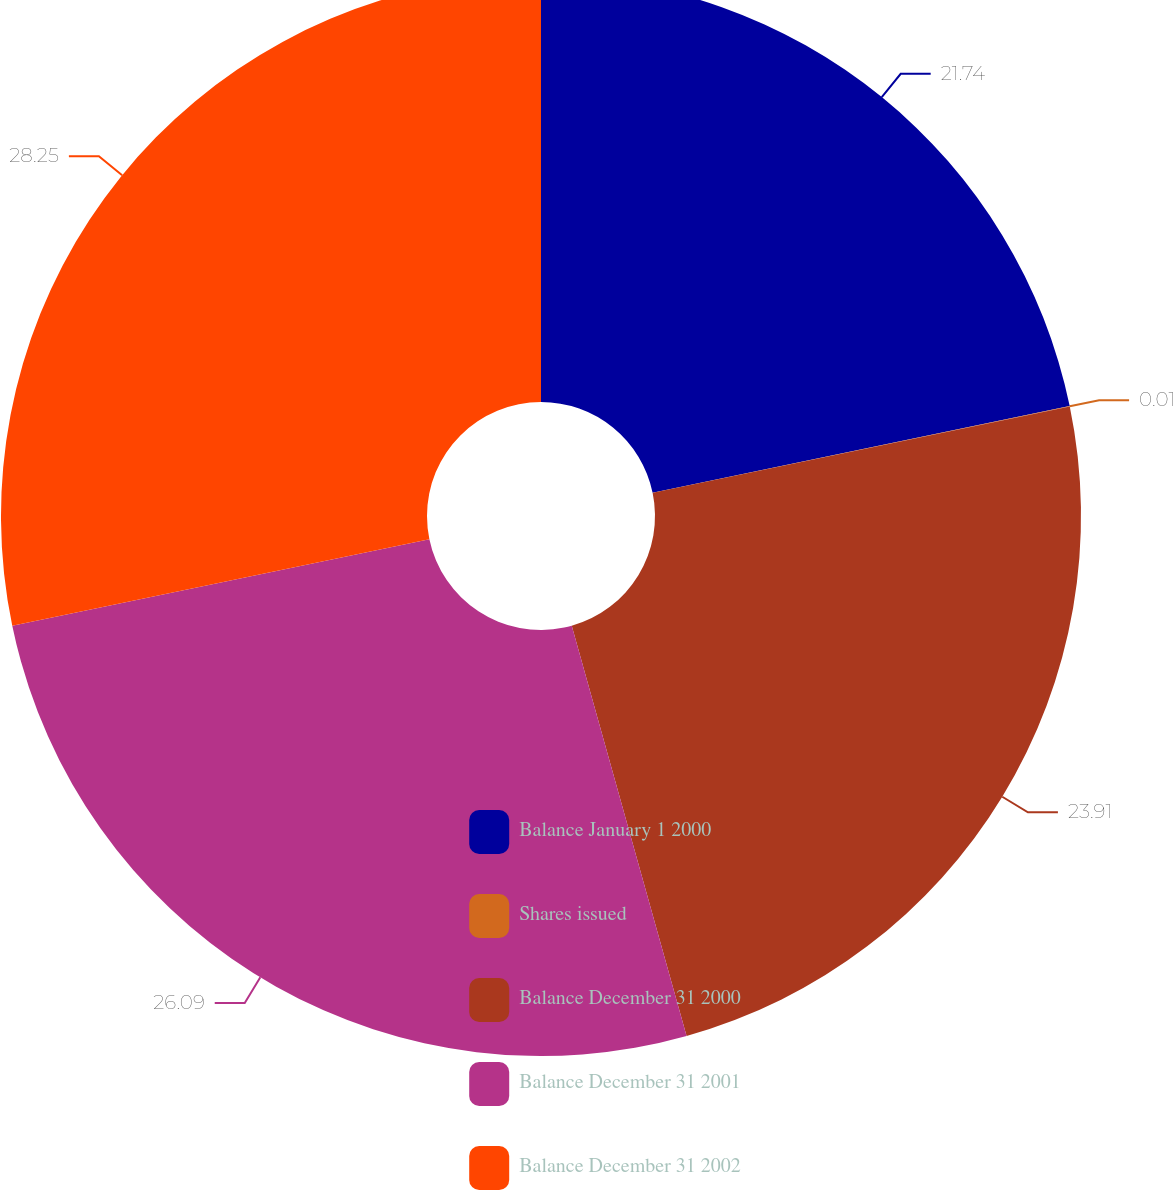Convert chart to OTSL. <chart><loc_0><loc_0><loc_500><loc_500><pie_chart><fcel>Balance January 1 2000<fcel>Shares issued<fcel>Balance December 31 2000<fcel>Balance December 31 2001<fcel>Balance December 31 2002<nl><fcel>21.74%<fcel>0.01%<fcel>23.91%<fcel>26.09%<fcel>28.26%<nl></chart> 